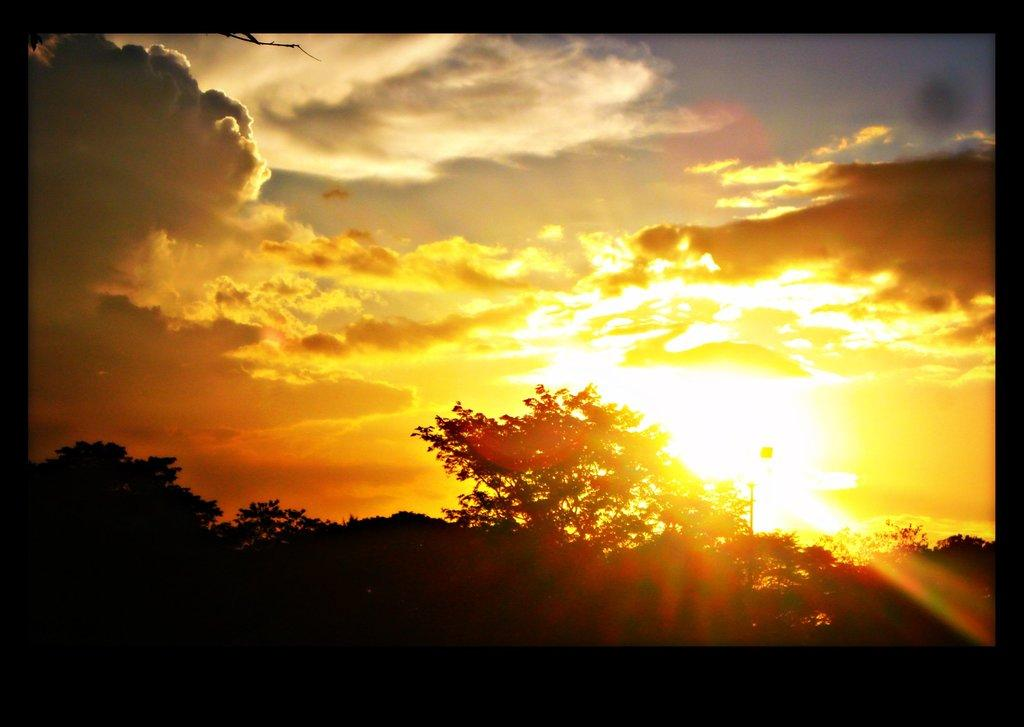What type of vegetation can be seen at the ground level in the image? There are trees at the ground level in the image. What can be seen in the sky in the image? There are clouds and the sun visible in the sky in the image. What type of gold object is visible in the image? There is no gold object present in the image. Is there any fire visible in the image? There is no fire visible in the image. 